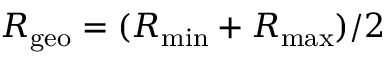<formula> <loc_0><loc_0><loc_500><loc_500>R _ { g e o } = ( R _ { \min } + R _ { \max } ) / 2</formula> 